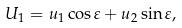<formula> <loc_0><loc_0><loc_500><loc_500>U _ { 1 } = u _ { 1 } \cos \varepsilon + u _ { 2 } \sin \varepsilon ,</formula> 